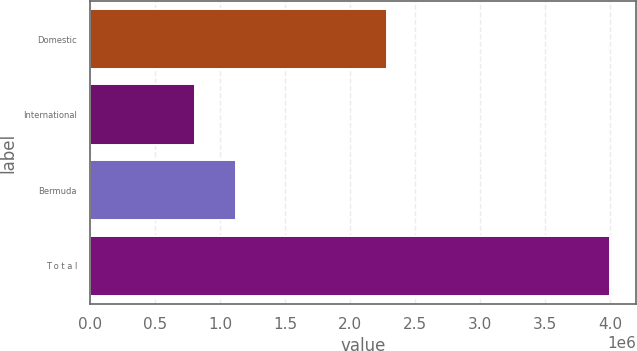Convert chart. <chart><loc_0><loc_0><loc_500><loc_500><bar_chart><fcel>Domestic<fcel>International<fcel>Bermuda<fcel>T o t a l<nl><fcel>2.28078e+06<fcel>803830<fcel>1.1232e+06<fcel>3.9975e+06<nl></chart> 